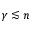Convert formula to latex. <formula><loc_0><loc_0><loc_500><loc_500>\gamma \lesssim n</formula> 